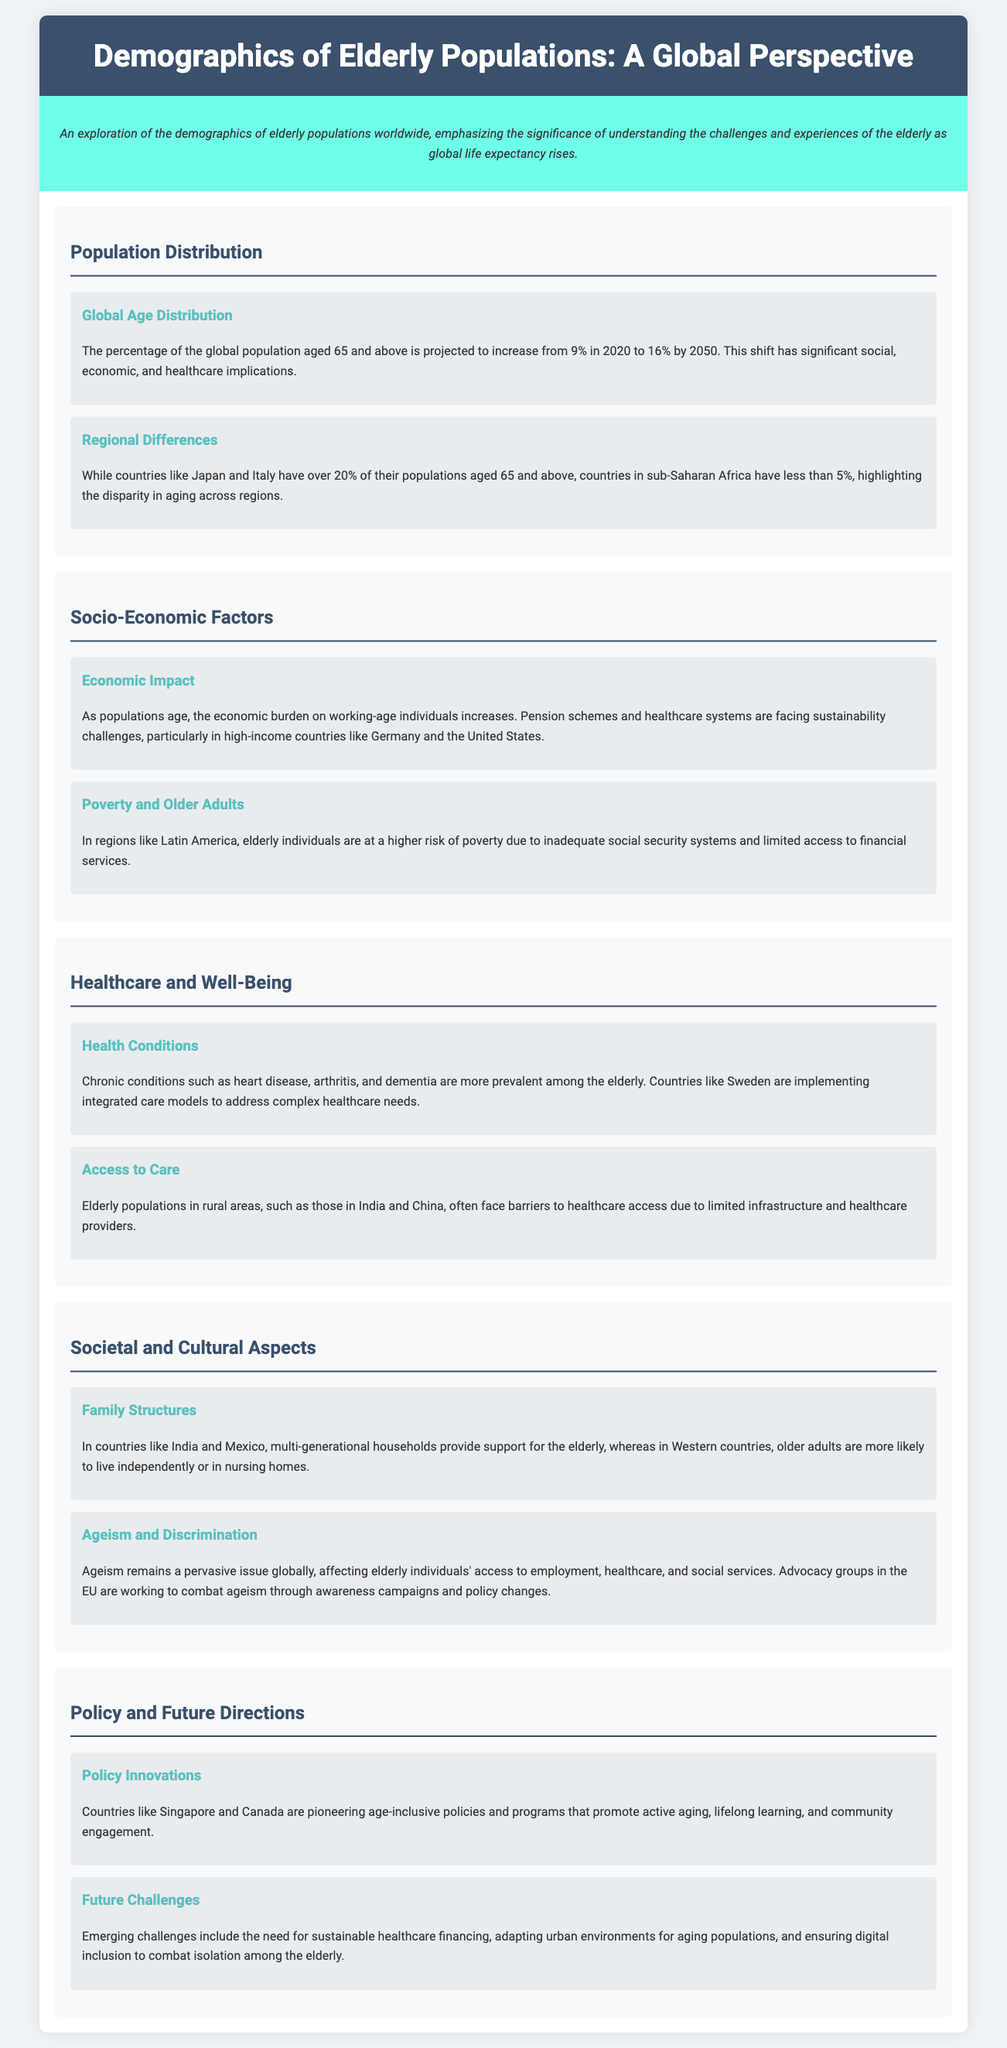What is the projected percentage of the global population aged 65 and above by 2050? The document states that the percentage is projected to increase to 16% by 2050.
Answer: 16% Which country has over 20% of its population aged 65 and above? Japan and Italy are mentioned as countries with over 20% of their populations aged 65 and above.
Answer: Japan and Italy What is a significant economic challenge faced by high-income countries? The document highlights sustainability challenges for pension schemes and healthcare systems as a significant economic burden.
Answer: Sustainability challenges What chronic conditions are more prevalent among the elderly? The document lists heart disease, arthritis, and dementia as chronic conditions that are more prevalent among elderly populations.
Answer: Heart disease, arthritis, and dementia How do family structures differ between countries like India and Western countries regarding the elderly? In India and Mexico, multi-generational households provide support for the elderly, whereas in Western countries, older adults are more likely to live independently or in nursing homes.
Answer: Multi-generational households vs. independent living What kind of policies are countries like Singapore and Canada implementing? The document mentions that these countries are pioneering age-inclusive policies and programs promoting active aging and community engagement.
Answer: Age-inclusive policies What prevalent issue affects elderly individuals' access to various services? Ageism is indicated as a pervasive issue affecting elderly individuals' access to employment, healthcare, and social services.
Answer: Ageism What does the document suggest as a future challenge for aging populations? The document points out the need for sustainable healthcare financing as an emerging future challenge.
Answer: Sustainable healthcare financing 